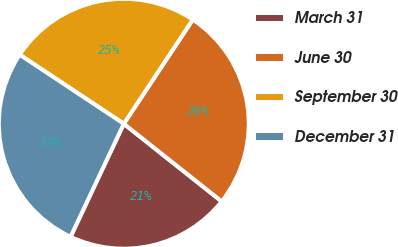<chart> <loc_0><loc_0><loc_500><loc_500><pie_chart><fcel>March 31<fcel>June 30<fcel>September 30<fcel>December 31<nl><fcel>21.33%<fcel>26.36%<fcel>24.99%<fcel>27.31%<nl></chart> 